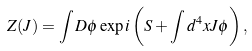Convert formula to latex. <formula><loc_0><loc_0><loc_500><loc_500>Z ( J ) = \int D \phi \exp i \left ( S + \int d ^ { 4 } x J \phi \right ) ,</formula> 